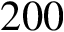<formula> <loc_0><loc_0><loc_500><loc_500>2 0 0</formula> 